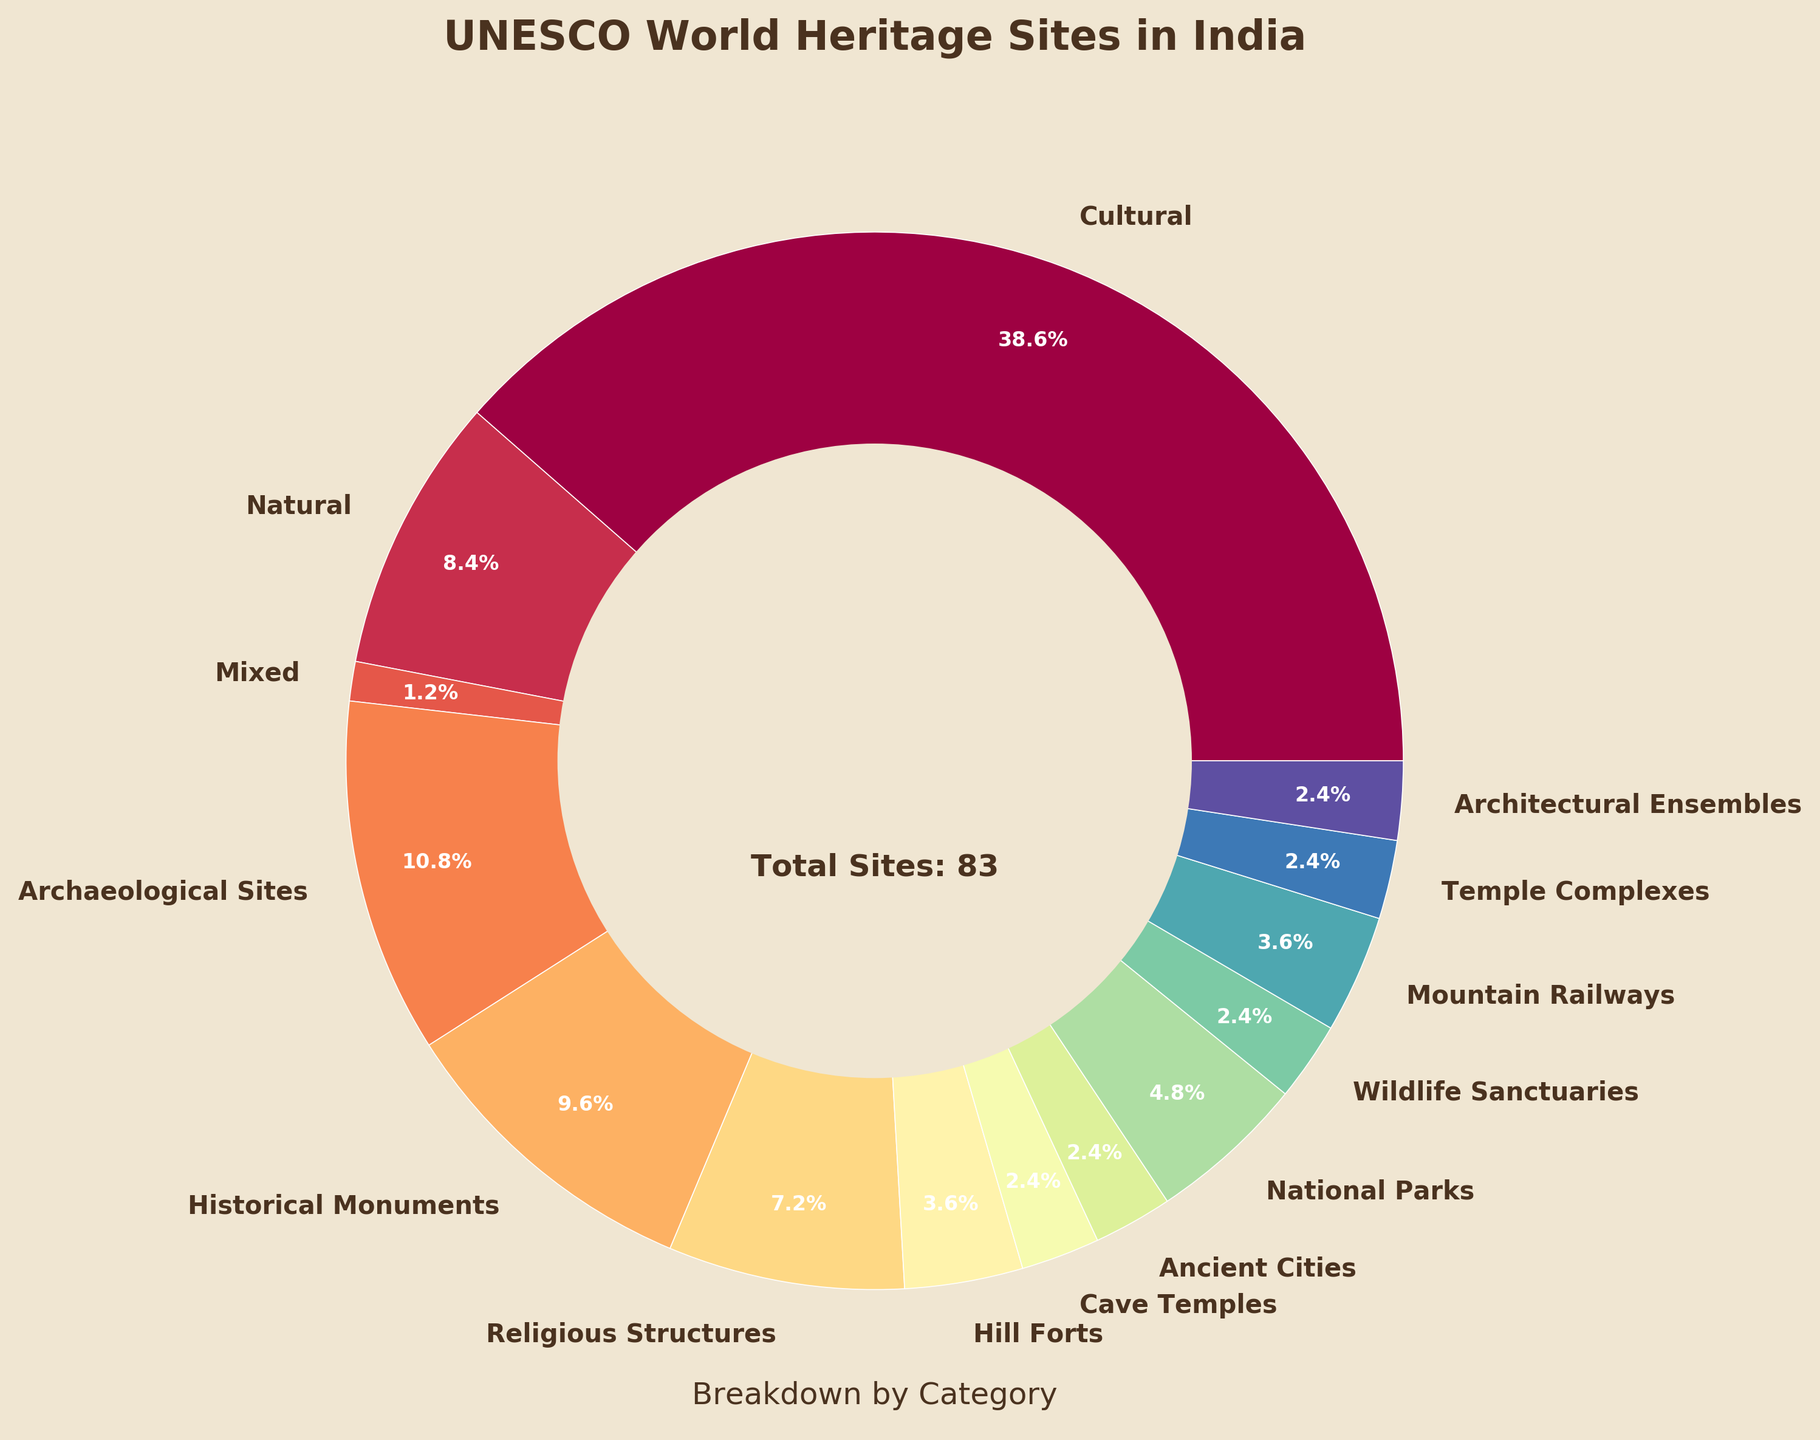What is the largest category of UNESCO World Heritage Sites in India? The largest category can be identified by looking at the slice with the highest percentage. The "Cultural" category has the largest slice with 32 sites.
Answer: Cultural What percentage of sites are Natural? The Natural category's percentage is directly labeled in the pie chart. According to the pie chart, it is 7 sites out of the total, which form a specific percentage.
Answer: 14.6% How many more Cultural sites are there compared to Natural sites? The number of Cultural sites is 32 and the number of Natural sites is 7. Subtracting the two gives the difference: 32 - 7.
Answer: 25 Which categories have exactly two sites? The pie chart shows the categories with their respective number of sites, and we can see which ones have exactly two. "Cave Temples," "Ancient Cities," "Temple Complexes," and "Architectural Ensembles" each have two sites.
Answer: Cave Temples, Ancient Cities, Temple Complexes, Architectural Ensembles How does the number of Historical Monuments compare to Archaeological Sites? The number of Historical Monuments is 8 and the number of Archaeological Sites is 9. It can be compared by simple observation of the numbers.
Answer: Historical Monuments: 8, Archaeological Sites: 9 Which category represents the smallest percentage of the total sites? By examining the smallest slices in the pie chart, it's clear that the "Mixed" category, with only 1 site, represents the smallest percentage.
Answer: Mixed If we combine all the categories with less than 5 sites, what percentage of the total do they make up? Categories with fewer than 5 sites are: Mixed (1), Hill Forts (3), Cave Temples (2), Ancient Cities (2), Wildlife Sanctuaries (2), Mountain Railways (3), Temple Complexes (2), Architectural Ensembles (2). Summing these up gives us: 1 + 3 + 2 + 2 + 2 + 3 + 2 + 2 = 17. Then convert this into a percentage: (17/78) * 100.
Answer: 21.8% What is the total number of UNESCO World Heritage Sites in India? The total number of sites can be identified from the annotation in the plotted figure summarizing the sites.
Answer: 78 Are there more Hill Forts or National Parks? By comparing the two categories visually, National Parks (4) have more sites than Hill Forts (3).
Answer: National Parks How many categories have more than 10 sites? By examining the labeled slices and counting the categories with more than 10 sites, we see "Cultural" is the only category with more than 10 sites.
Answer: 1 